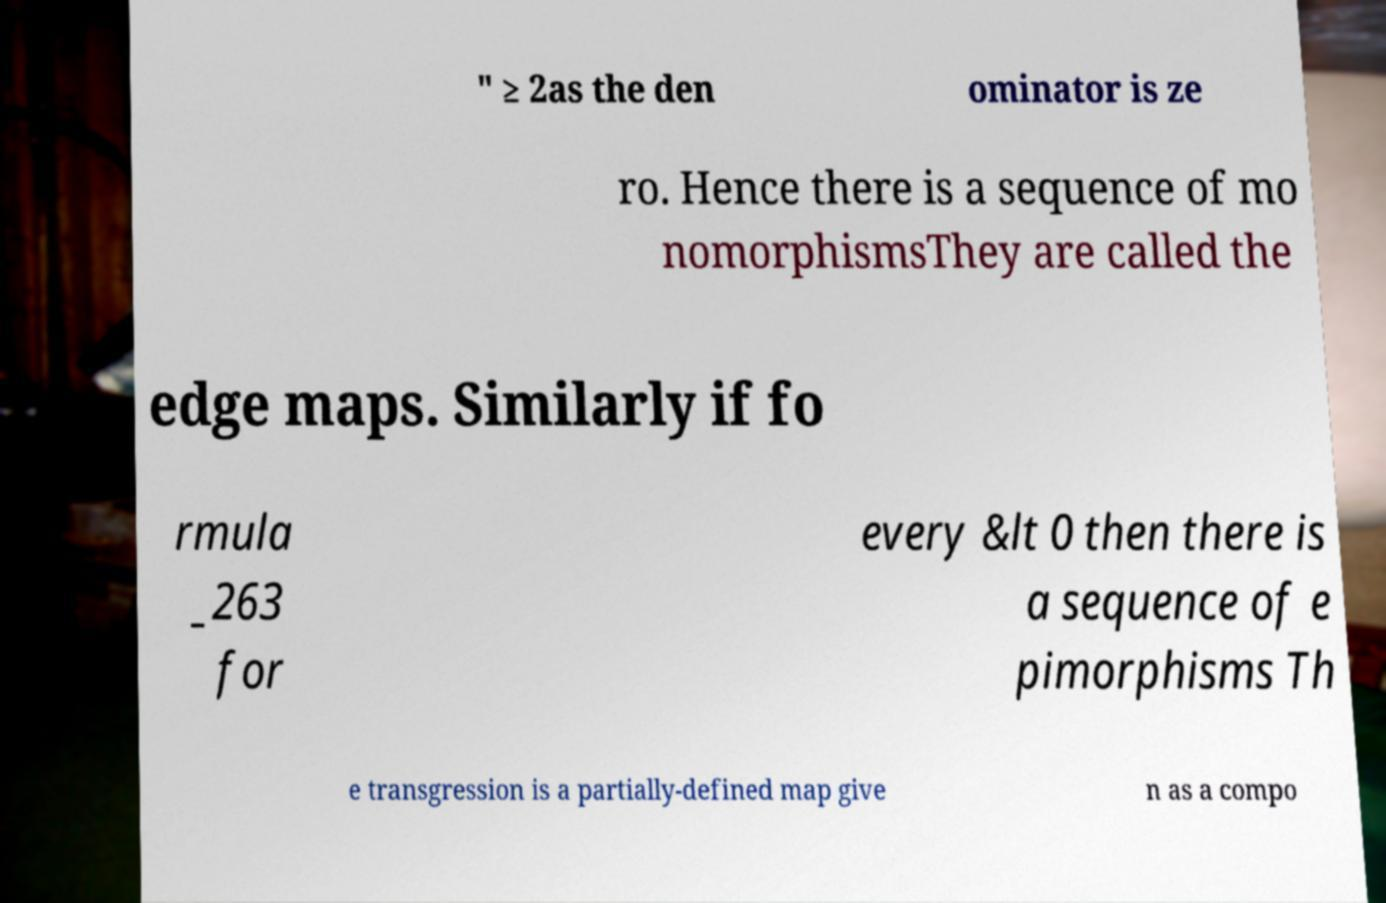Could you extract and type out the text from this image? " ≥ 2as the den ominator is ze ro. Hence there is a sequence of mo nomorphismsThey are called the edge maps. Similarly if fo rmula _263 for every &lt 0 then there is a sequence of e pimorphisms Th e transgression is a partially-defined map give n as a compo 